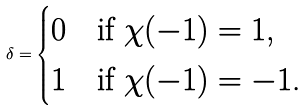<formula> <loc_0><loc_0><loc_500><loc_500>\delta = \begin{cases} 0 & \text {if $\chi(-1)=1$,} \\ 1 & \text {if $\chi(-1)=-1$.} \end{cases}</formula> 